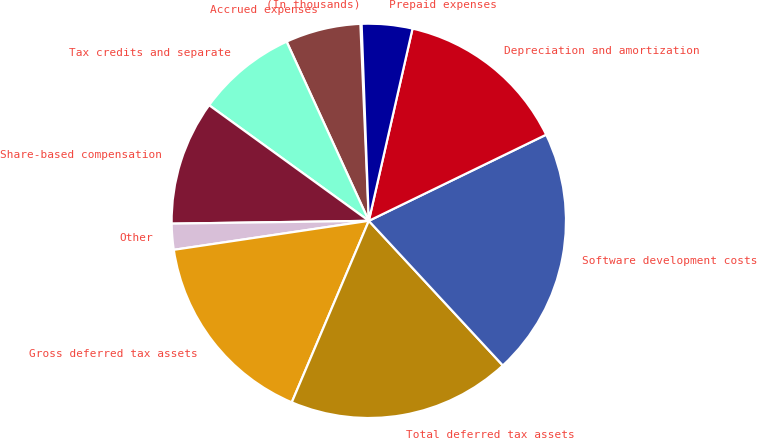Convert chart to OTSL. <chart><loc_0><loc_0><loc_500><loc_500><pie_chart><fcel>(In thousands)<fcel>Accrued expenses<fcel>Tax credits and separate<fcel>Share-based compensation<fcel>Other<fcel>Gross deferred tax assets<fcel>Total deferred tax assets<fcel>Software development costs<fcel>Depreciation and amortization<fcel>Prepaid expenses<nl><fcel>0.1%<fcel>6.16%<fcel>8.18%<fcel>10.2%<fcel>2.12%<fcel>16.26%<fcel>18.28%<fcel>20.3%<fcel>14.24%<fcel>4.14%<nl></chart> 